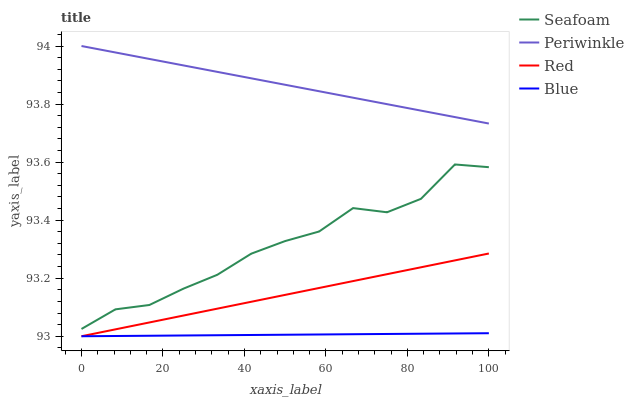Does Blue have the minimum area under the curve?
Answer yes or no. Yes. Does Seafoam have the minimum area under the curve?
Answer yes or no. No. Does Seafoam have the maximum area under the curve?
Answer yes or no. No. Is Seafoam the roughest?
Answer yes or no. Yes. Is Seafoam the smoothest?
Answer yes or no. No. Is Periwinkle the roughest?
Answer yes or no. No. Does Seafoam have the lowest value?
Answer yes or no. No. Does Seafoam have the highest value?
Answer yes or no. No. Is Seafoam less than Periwinkle?
Answer yes or no. Yes. Is Seafoam greater than Blue?
Answer yes or no. Yes. Does Seafoam intersect Periwinkle?
Answer yes or no. No. 